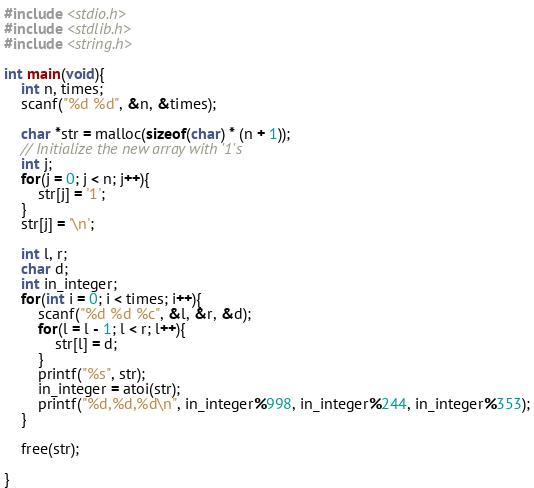<code> <loc_0><loc_0><loc_500><loc_500><_C_>#include <stdio.h>
#include <stdlib.h>
#include <string.h>

int main(void){
    int n, times;
    scanf("%d %d", &n, &times);

    char *str = malloc(sizeof(char) * (n + 1));
    // Initialize the new array with '1's
    int j;
    for(j = 0; j < n; j++){
        str[j] = '1';
    }
    str[j] = '\n';

    int l, r;
    char d;
    int in_integer;
    for(int i = 0; i < times; i++){
        scanf("%d %d %c", &l, &r, &d);
        for(l = l - 1; l < r; l++){
            str[l] = d;
        }
        printf("%s", str);
        in_integer = atoi(str);
        printf("%d,%d,%d\n", in_integer%998, in_integer%244, in_integer%353);
    }

    free(str);

}    


</code> 